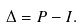Convert formula to latex. <formula><loc_0><loc_0><loc_500><loc_500>\Delta = P - I .</formula> 